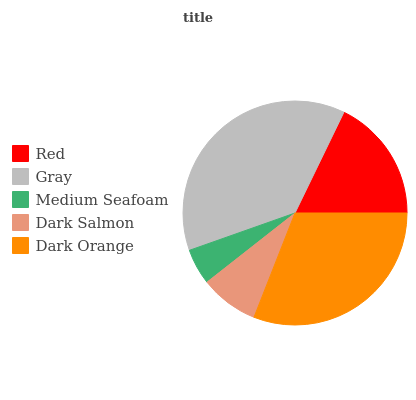Is Medium Seafoam the minimum?
Answer yes or no. Yes. Is Gray the maximum?
Answer yes or no. Yes. Is Gray the minimum?
Answer yes or no. No. Is Medium Seafoam the maximum?
Answer yes or no. No. Is Gray greater than Medium Seafoam?
Answer yes or no. Yes. Is Medium Seafoam less than Gray?
Answer yes or no. Yes. Is Medium Seafoam greater than Gray?
Answer yes or no. No. Is Gray less than Medium Seafoam?
Answer yes or no. No. Is Red the high median?
Answer yes or no. Yes. Is Red the low median?
Answer yes or no. Yes. Is Gray the high median?
Answer yes or no. No. Is Dark Salmon the low median?
Answer yes or no. No. 